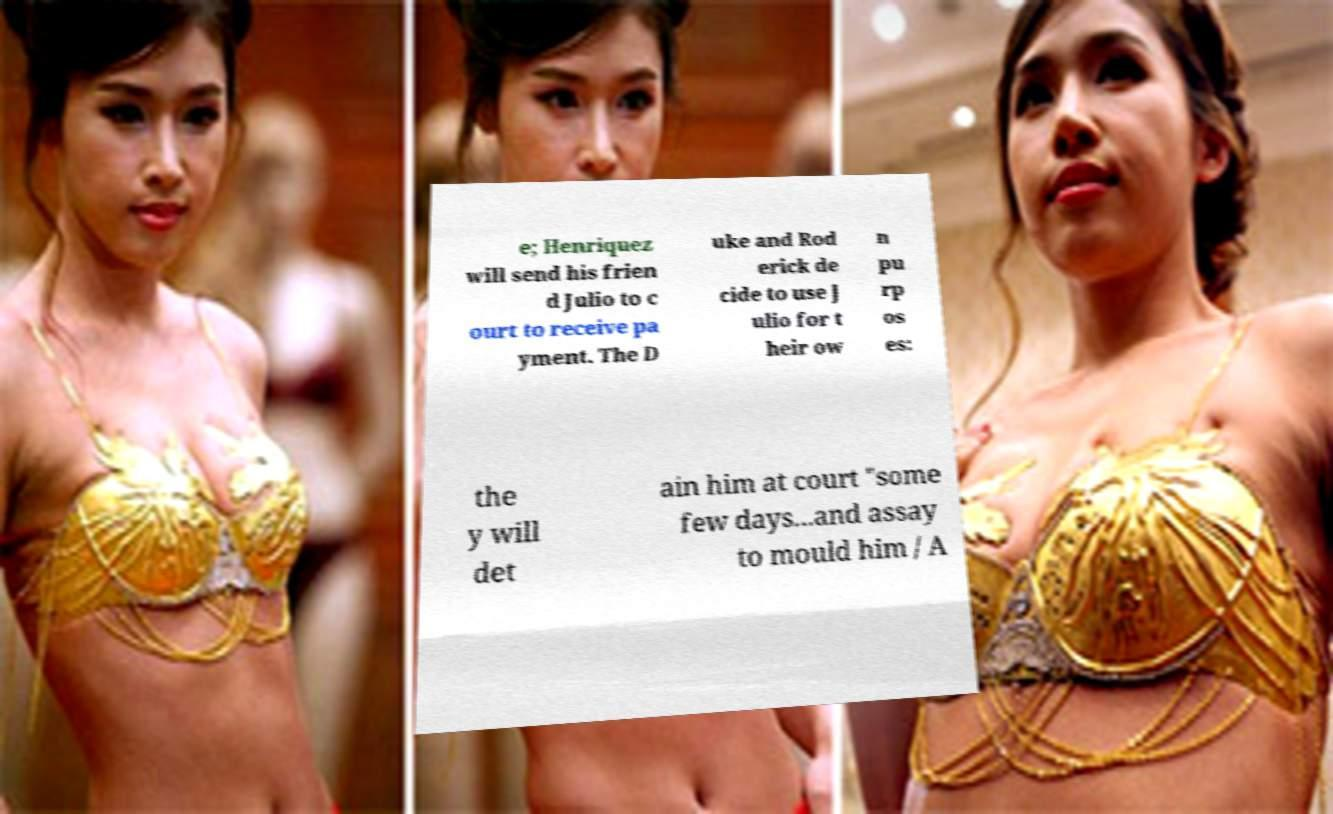Can you read and provide the text displayed in the image?This photo seems to have some interesting text. Can you extract and type it out for me? e; Henriquez will send his frien d Julio to c ourt to receive pa yment. The D uke and Rod erick de cide to use J ulio for t heir ow n pu rp os es: the y will det ain him at court "some few days...and assay to mould him / A 